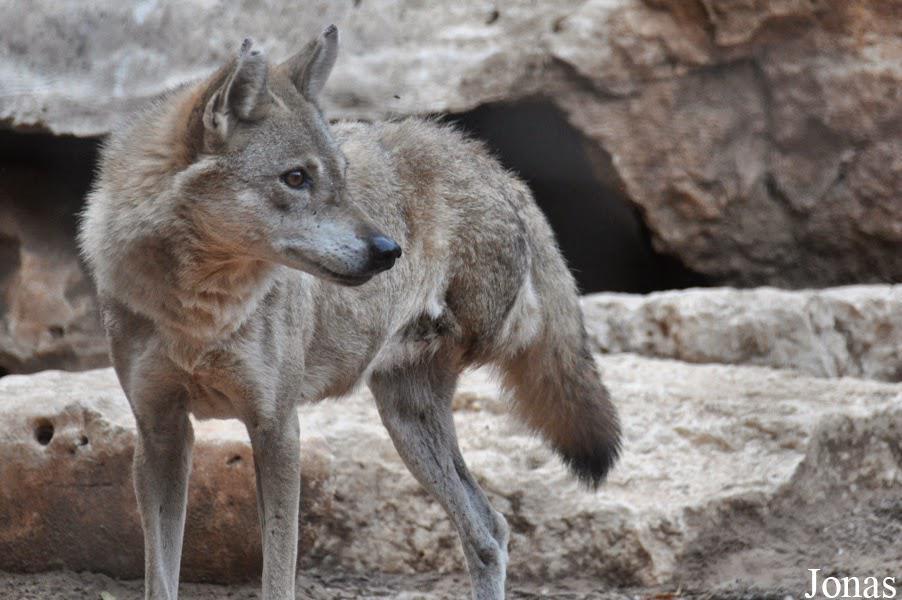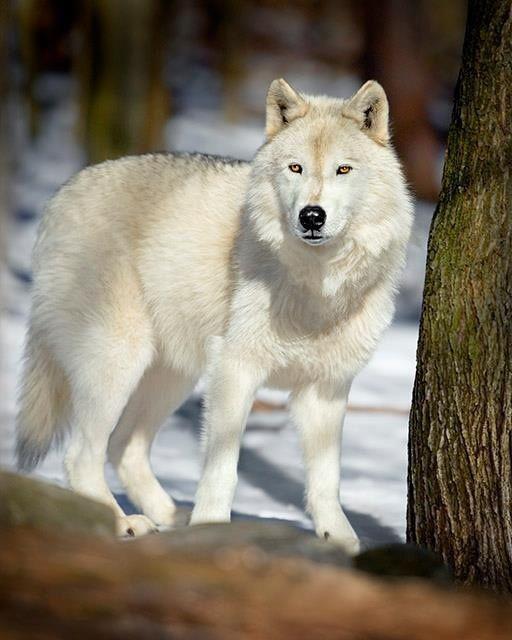The first image is the image on the left, the second image is the image on the right. Given the left and right images, does the statement "Each image contains two wolves, and one image shows the wolves standing on a boulder with tiers of boulders behind them." hold true? Answer yes or no. No. The first image is the image on the left, the second image is the image on the right. Considering the images on both sides, is "Two young white wolves are standing on a boulder." valid? Answer yes or no. No. 